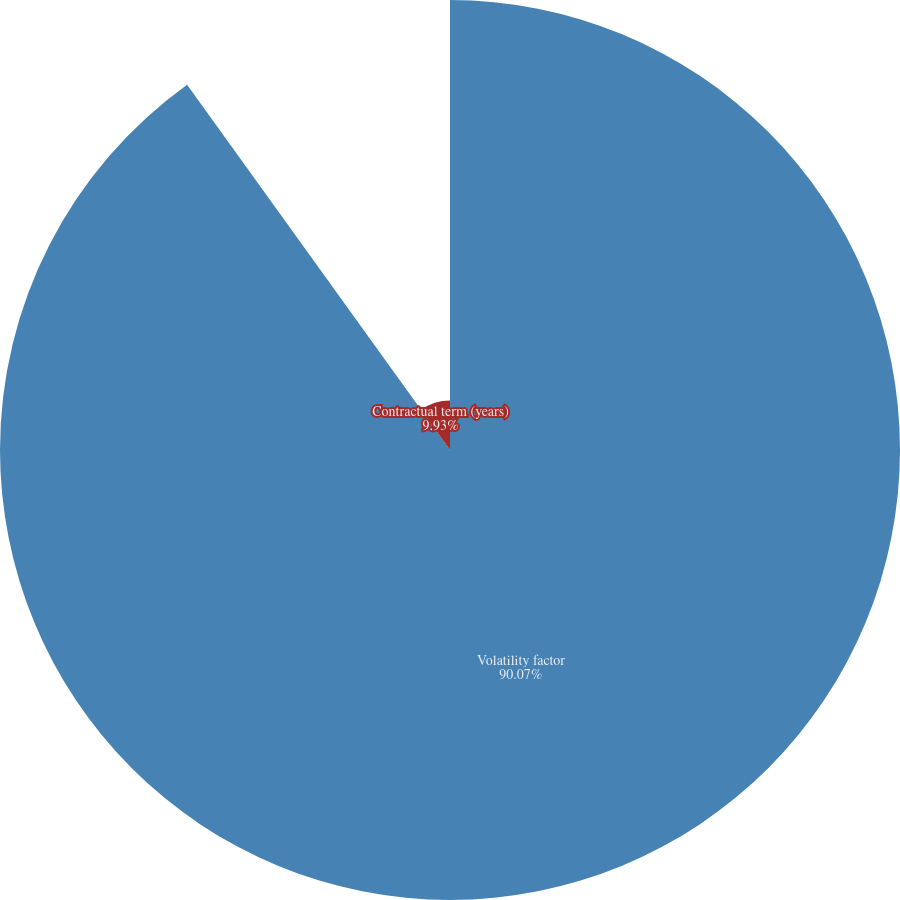<chart> <loc_0><loc_0><loc_500><loc_500><pie_chart><fcel>Volatility factor<fcel>Contractual term (years)<nl><fcel>90.07%<fcel>9.93%<nl></chart> 